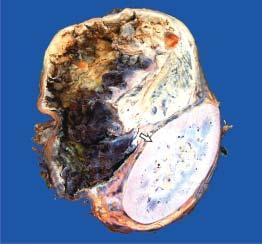does cut surface of tumour show cystic change while solid areas show dark brown, necrotic and haemorrhagic tumour?
Answer the question using a single word or phrase. Yes 